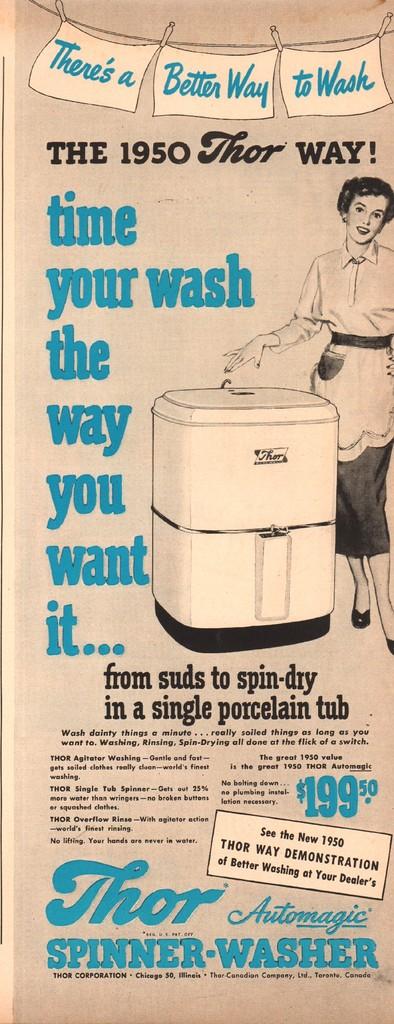How old is that washer machine?
Provide a succinct answer. 1950. What year was this ad created?
Provide a short and direct response. 1950. 